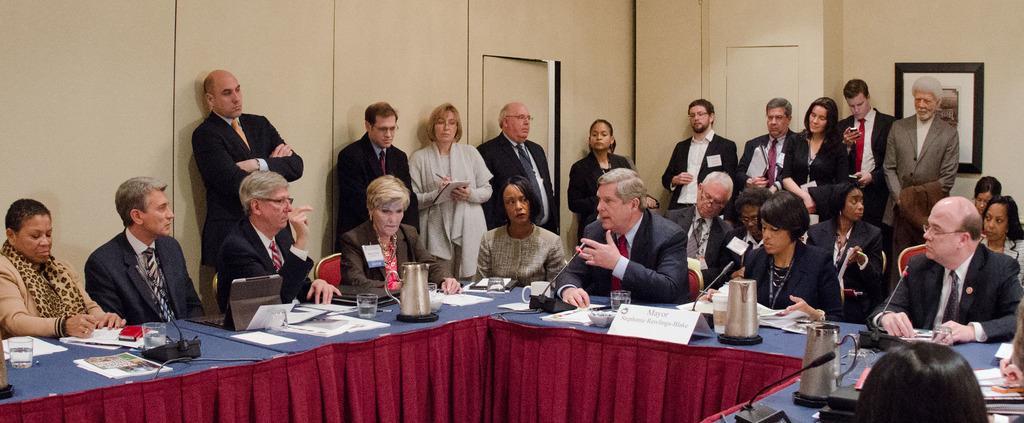Can you describe this image briefly? people are sitting on the chairs around the tables. on the table there are glass, pipes, microphones, jug and a name plate on which name plate is written. the person sitting in the center is speaking. there are people standing at the back. there is a photo frame on the wall. 